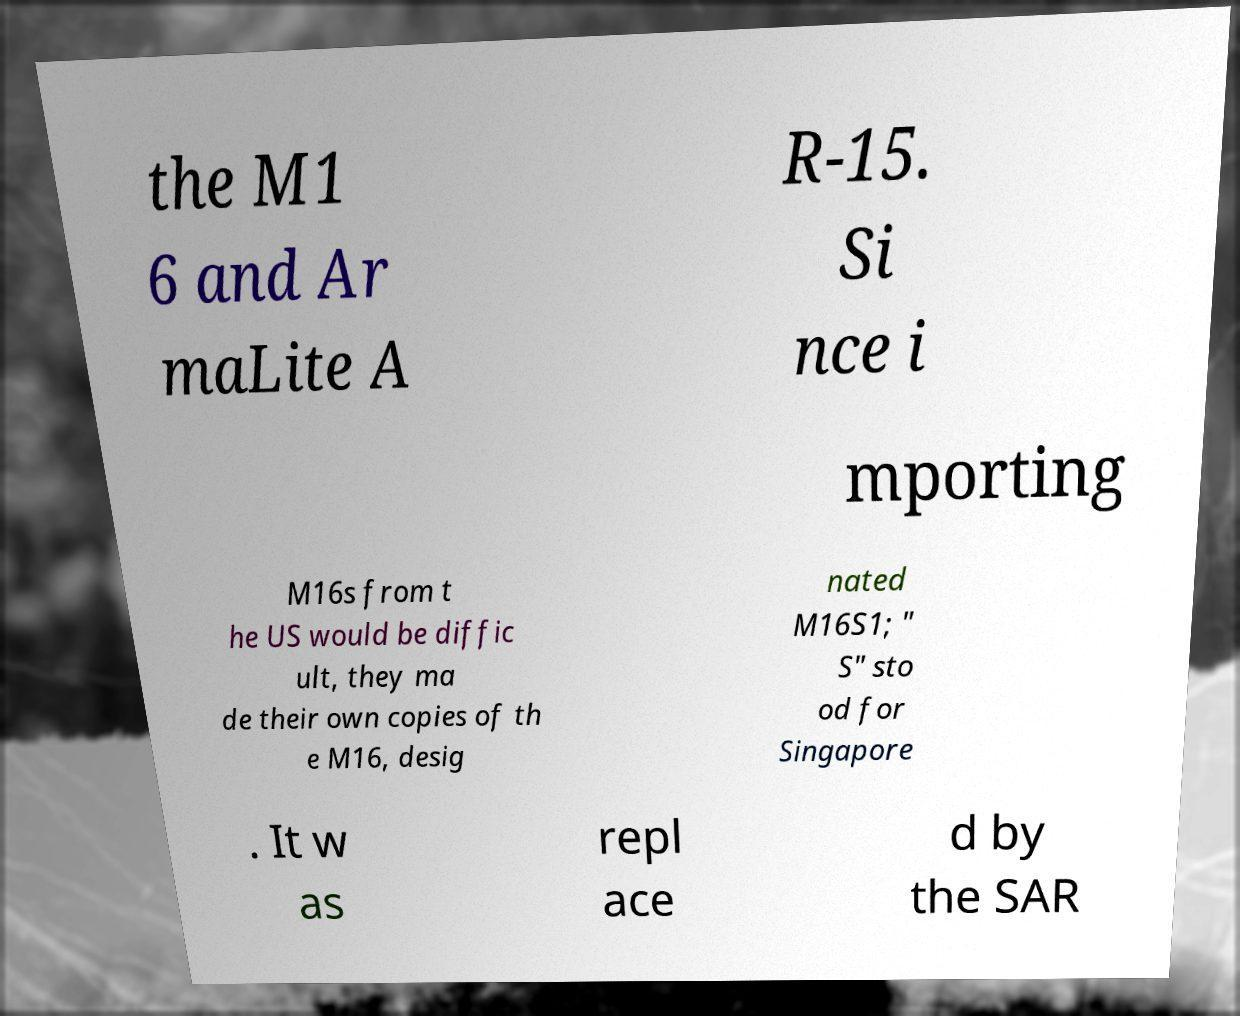Please read and relay the text visible in this image. What does it say? the M1 6 and Ar maLite A R-15. Si nce i mporting M16s from t he US would be diffic ult, they ma de their own copies of th e M16, desig nated M16S1; " S" sto od for Singapore . It w as repl ace d by the SAR 